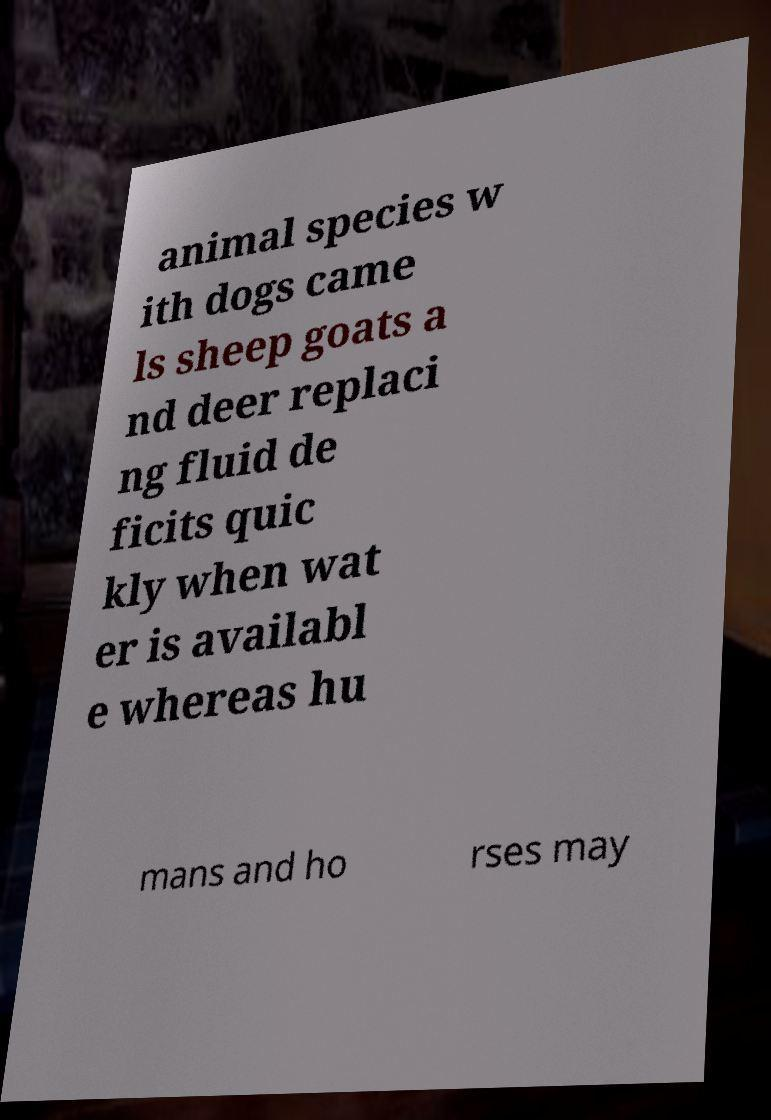I need the written content from this picture converted into text. Can you do that? animal species w ith dogs came ls sheep goats a nd deer replaci ng fluid de ficits quic kly when wat er is availabl e whereas hu mans and ho rses may 